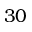Convert formula to latex. <formula><loc_0><loc_0><loc_500><loc_500>3 0</formula> 